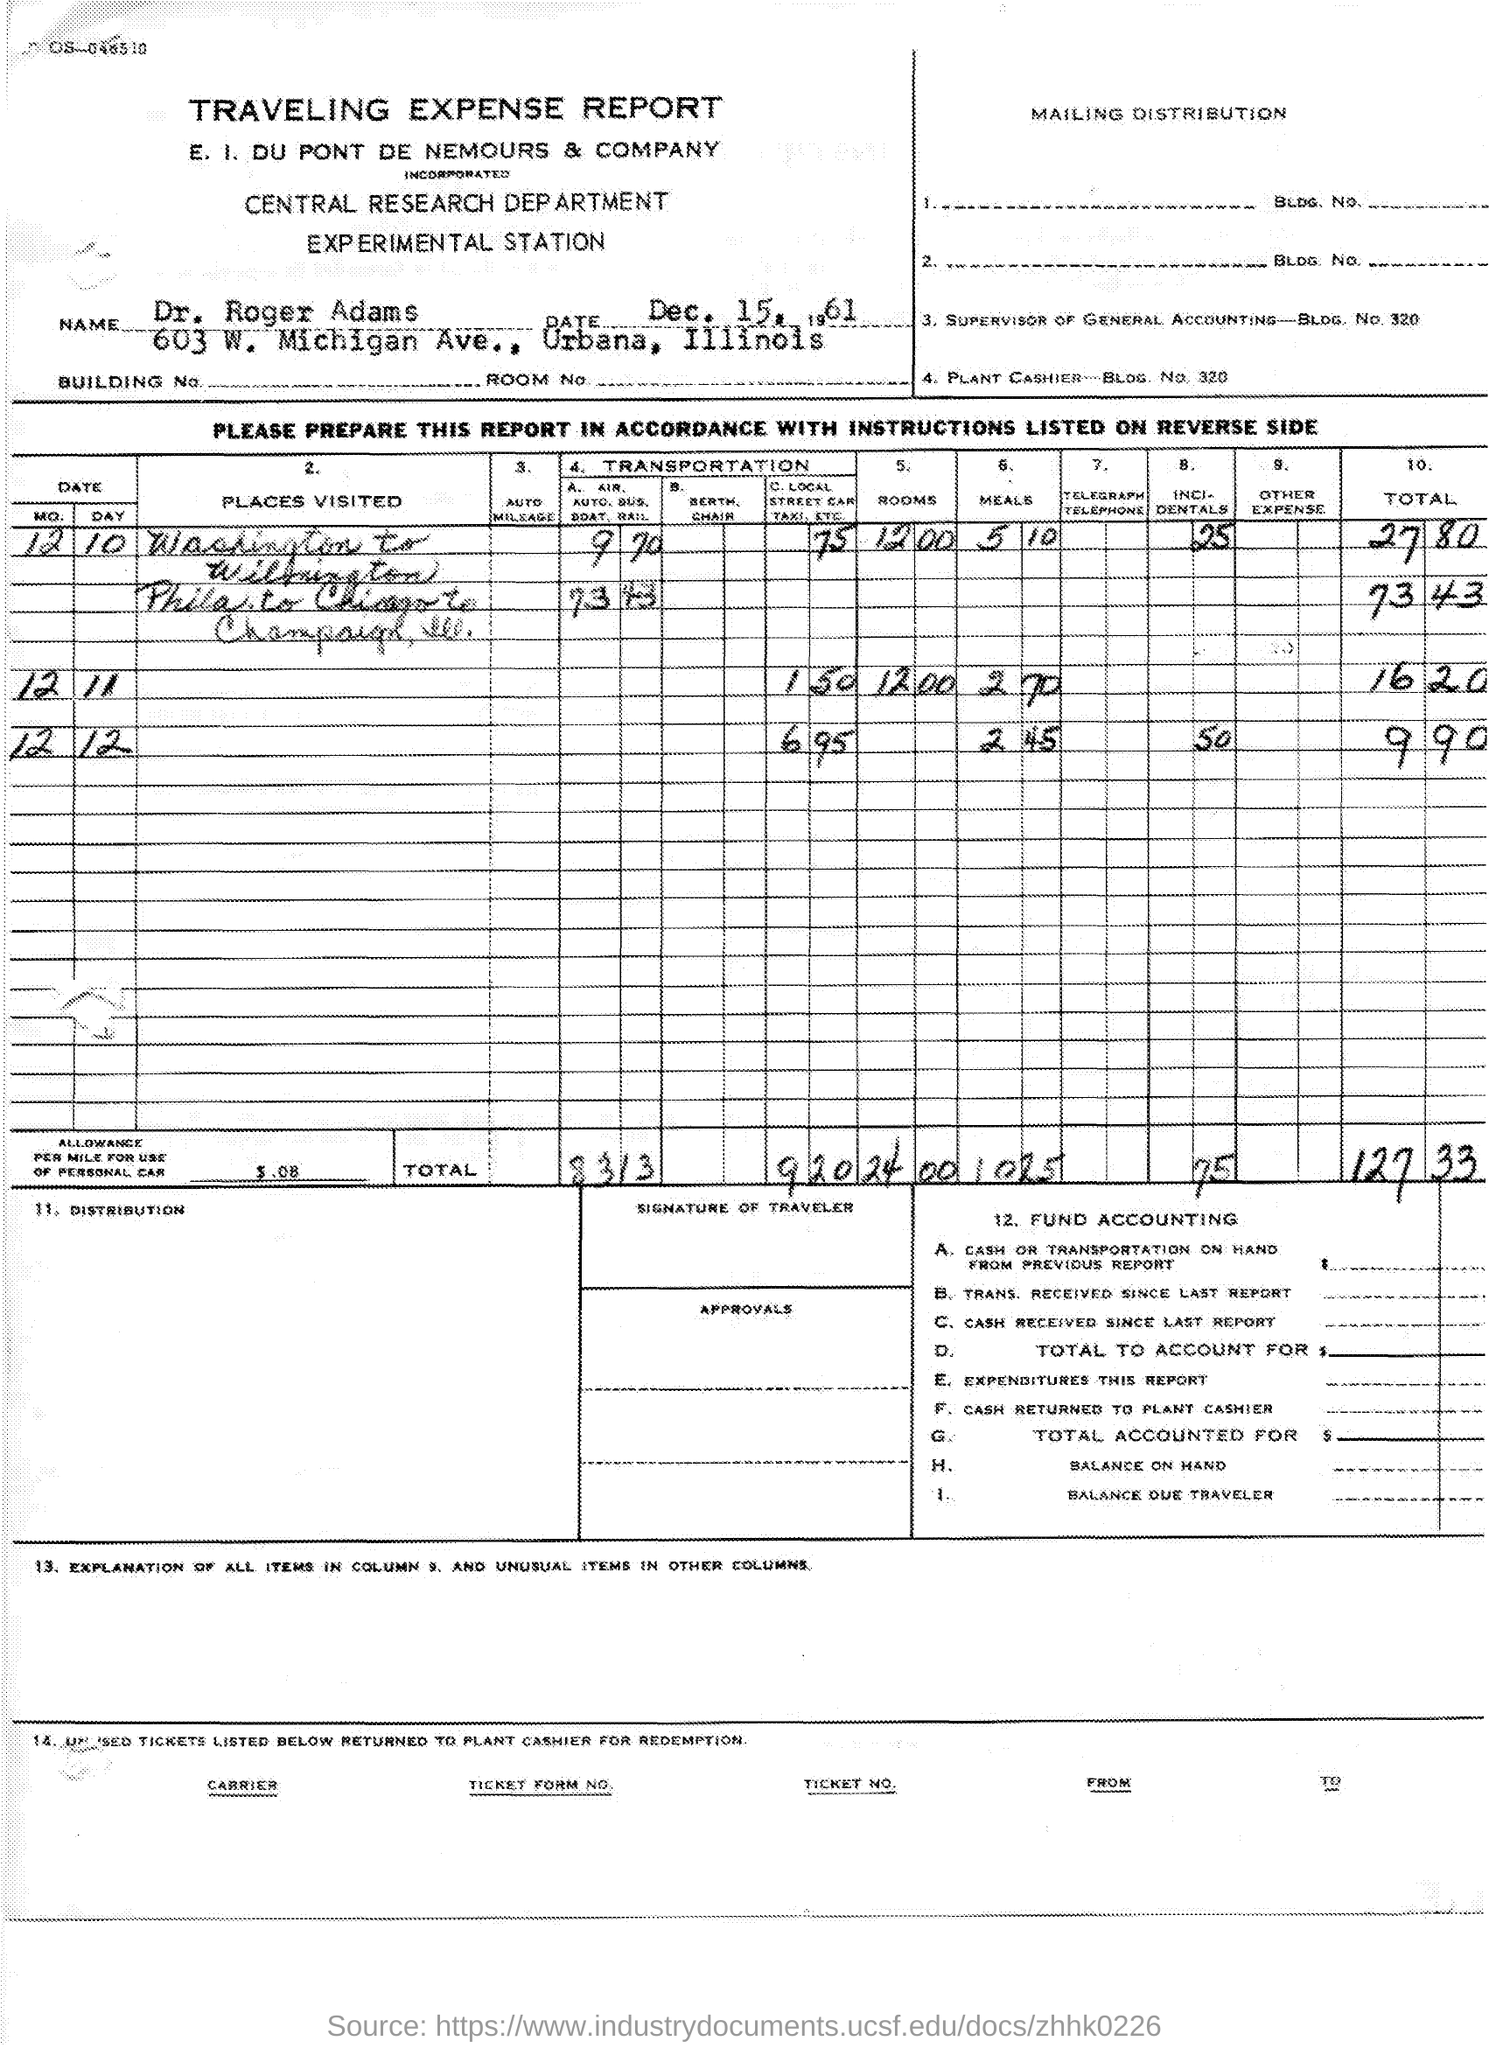What is the name of the report ?
Your response must be concise. TRAVELING EXPENSE REPORT. What is the name of the department mentioned in the given report ?
Your answer should be compact. Central research department. What is the date mentioned  in the given report ?
Make the answer very short. Dec. 15 , 1961. 